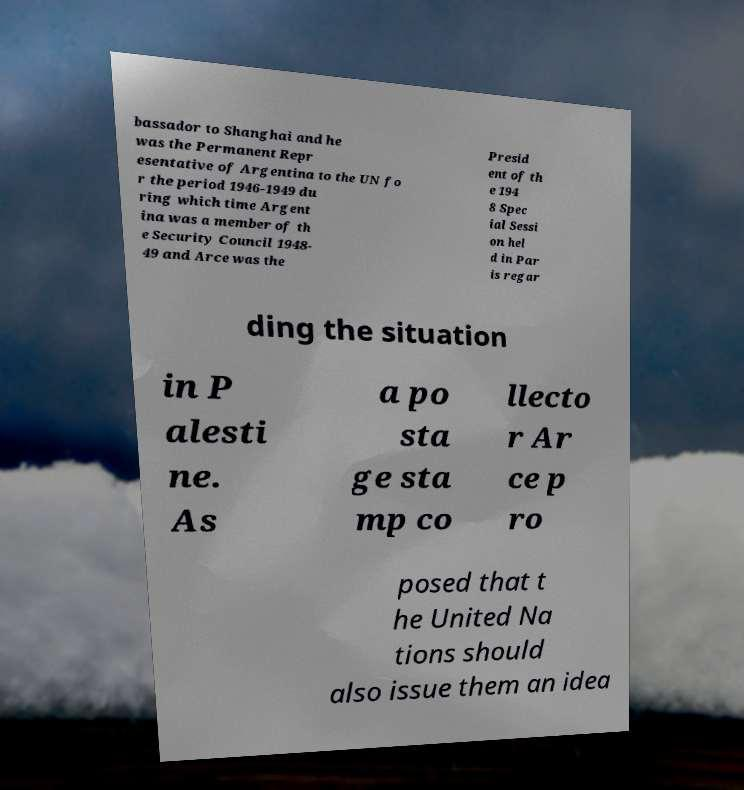For documentation purposes, I need the text within this image transcribed. Could you provide that? bassador to Shanghai and he was the Permanent Repr esentative of Argentina to the UN fo r the period 1946-1949 du ring which time Argent ina was a member of th e Security Council 1948- 49 and Arce was the Presid ent of th e 194 8 Spec ial Sessi on hel d in Par is regar ding the situation in P alesti ne. As a po sta ge sta mp co llecto r Ar ce p ro posed that t he United Na tions should also issue them an idea 